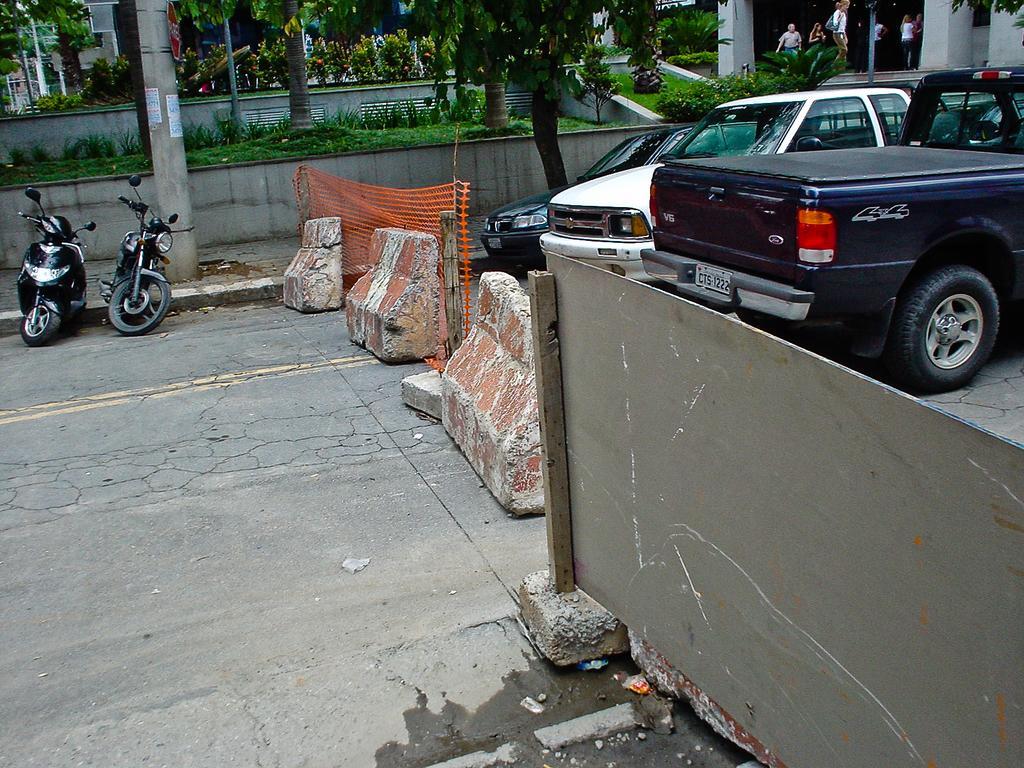Please provide a concise description of this image. This picture is clicked outside. On the right we can see the board and the stones and we can see the net and some wooden poles. On the left we can see the bikes parked on the ground. On the right we can see the vehicles parked on the ground. In the background we can see the group of people, pillars and we can see the green grass, plants, trees, flowers and some other objects. 